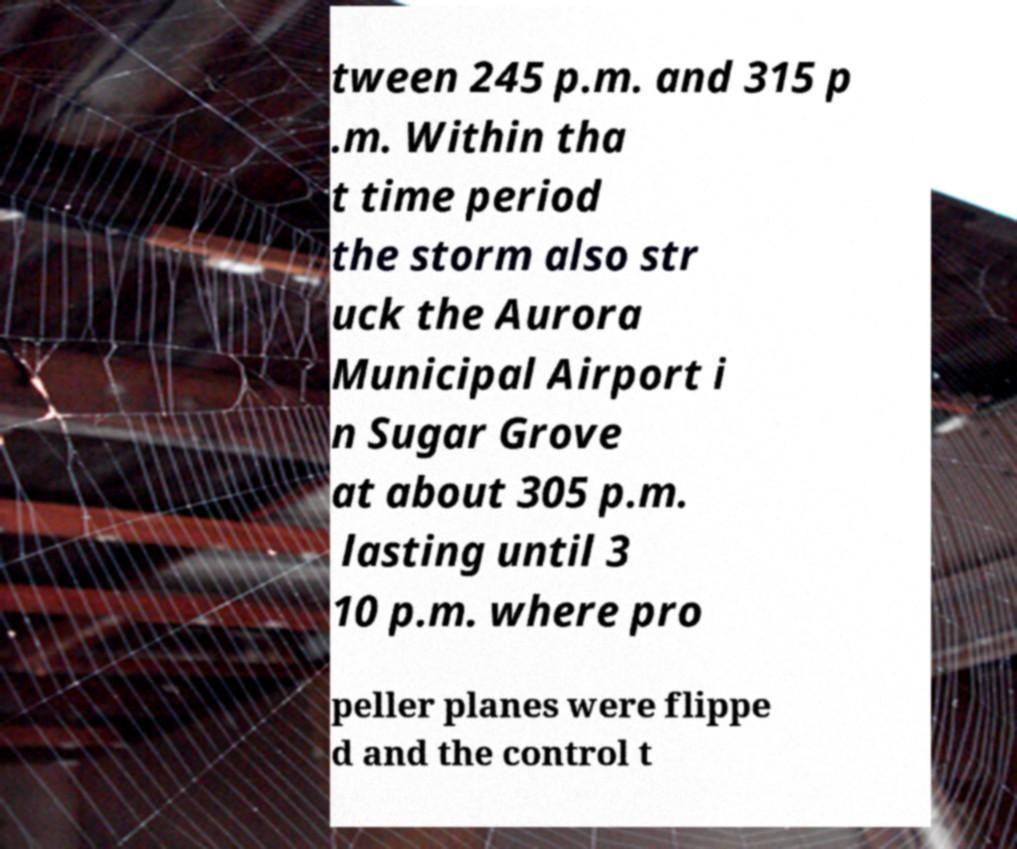Could you extract and type out the text from this image? tween 245 p.m. and 315 p .m. Within tha t time period the storm also str uck the Aurora Municipal Airport i n Sugar Grove at about 305 p.m. lasting until 3 10 p.m. where pro peller planes were flippe d and the control t 